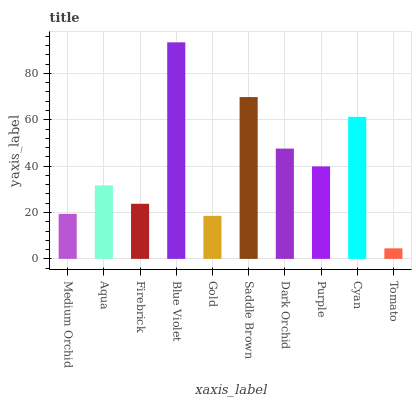Is Tomato the minimum?
Answer yes or no. Yes. Is Blue Violet the maximum?
Answer yes or no. Yes. Is Aqua the minimum?
Answer yes or no. No. Is Aqua the maximum?
Answer yes or no. No. Is Aqua greater than Medium Orchid?
Answer yes or no. Yes. Is Medium Orchid less than Aqua?
Answer yes or no. Yes. Is Medium Orchid greater than Aqua?
Answer yes or no. No. Is Aqua less than Medium Orchid?
Answer yes or no. No. Is Purple the high median?
Answer yes or no. Yes. Is Aqua the low median?
Answer yes or no. Yes. Is Cyan the high median?
Answer yes or no. No. Is Cyan the low median?
Answer yes or no. No. 